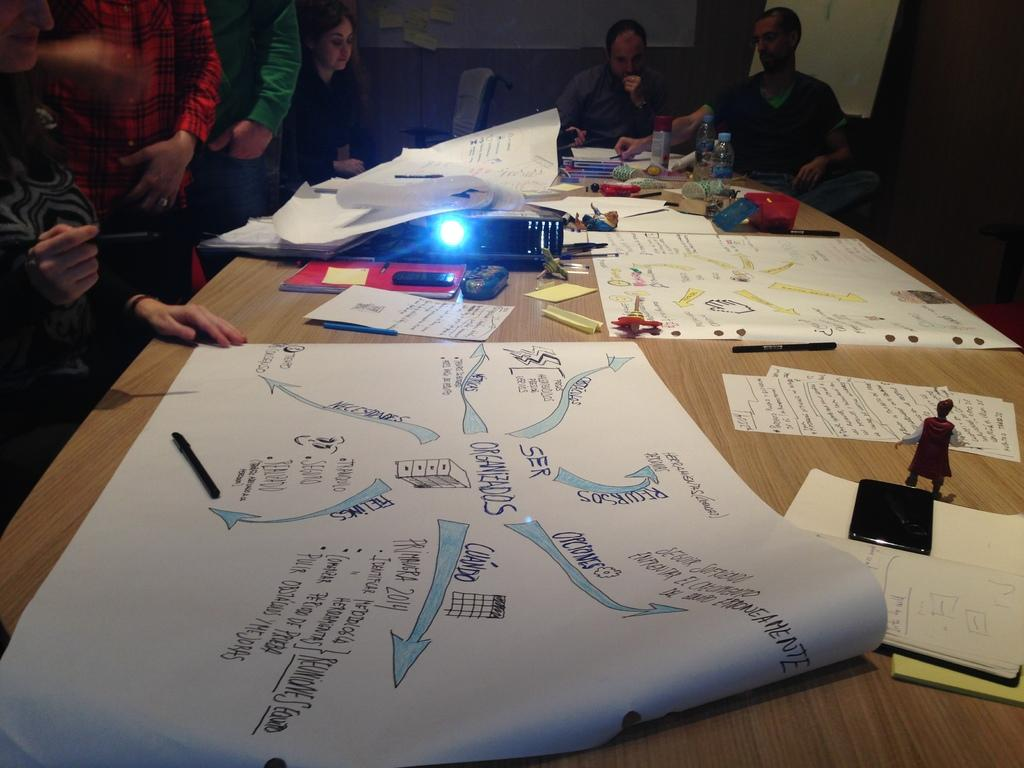How many people are in the image? There is a group of people in the image. What are the people doing in the image? The people are sitting on chairs. What is on the table in the image? There is a table in the image with charts on it. What other object is on the table in the image? There is a projector on the table. What type of story is being told by the flag in the image? There is no flag present in the image, so it is not possible to answer that question. 